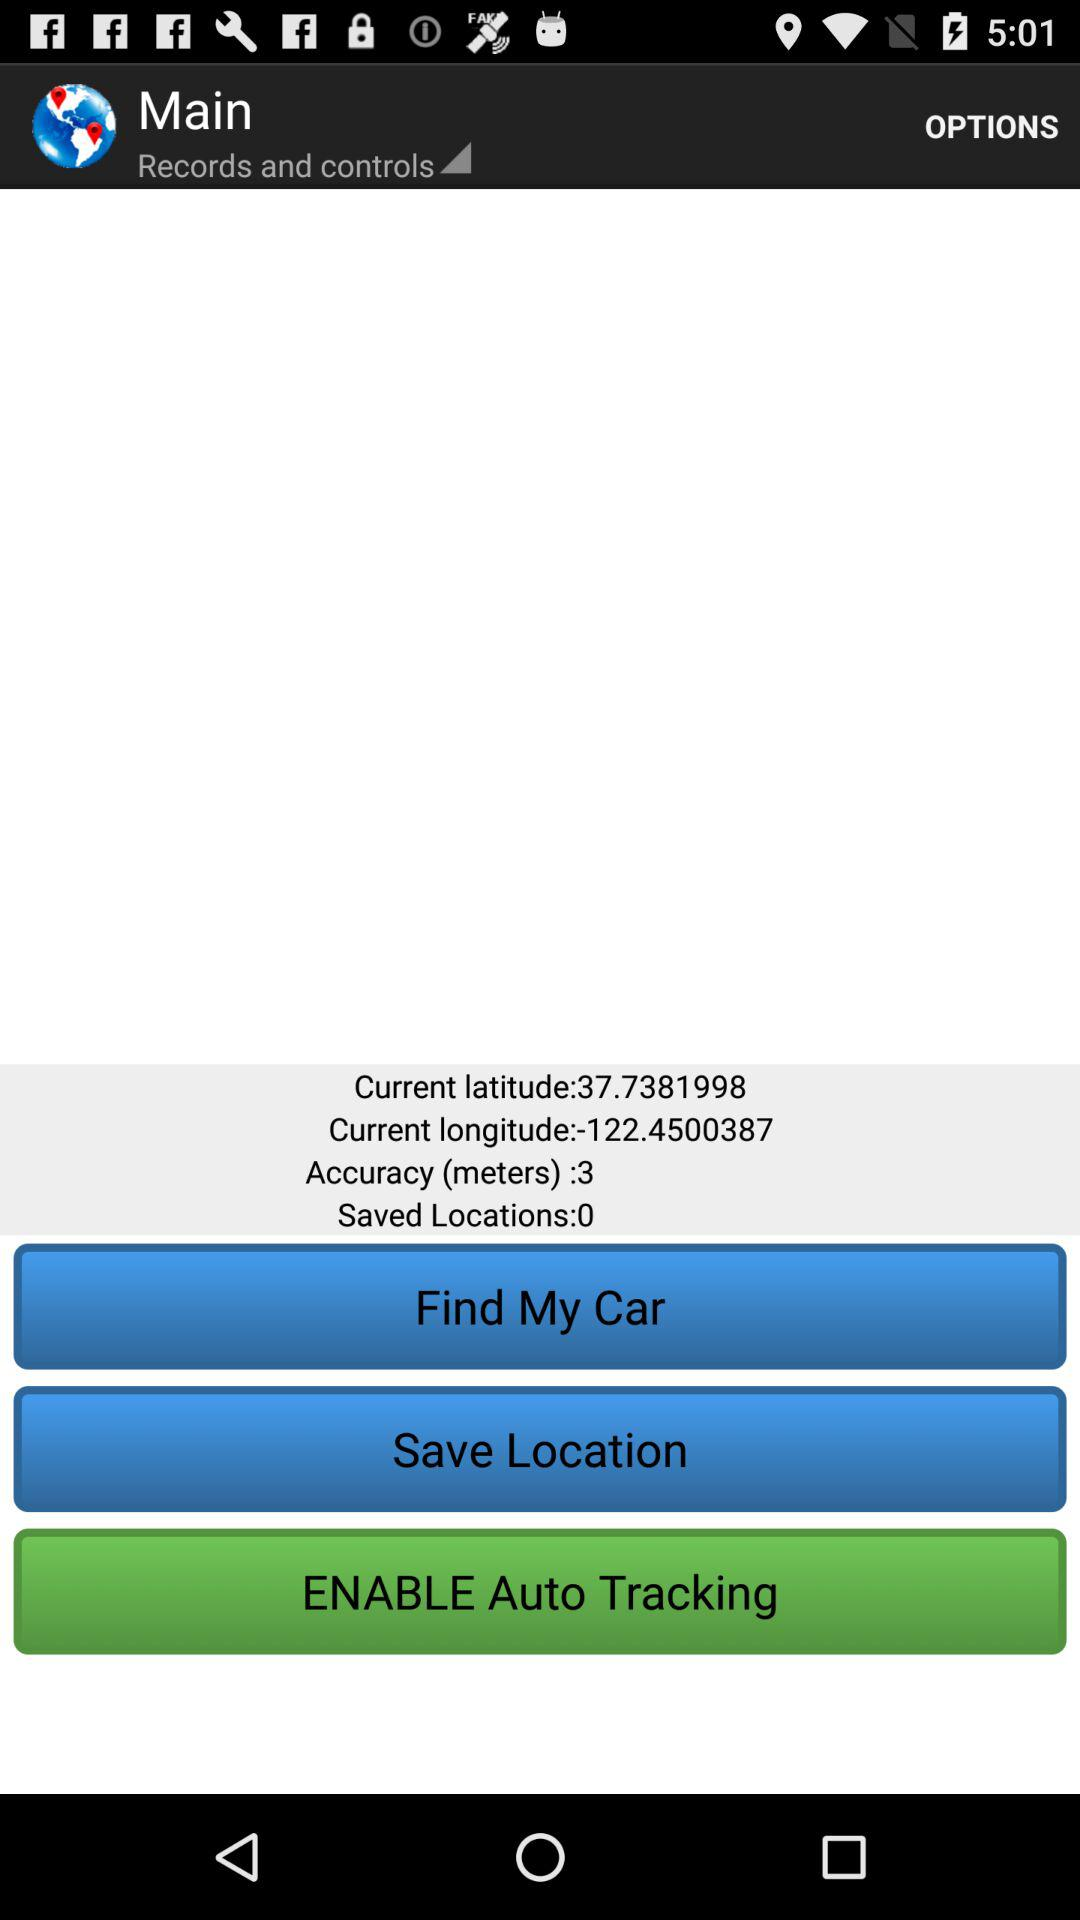How many locations have been saved?
Answer the question using a single word or phrase. 0 